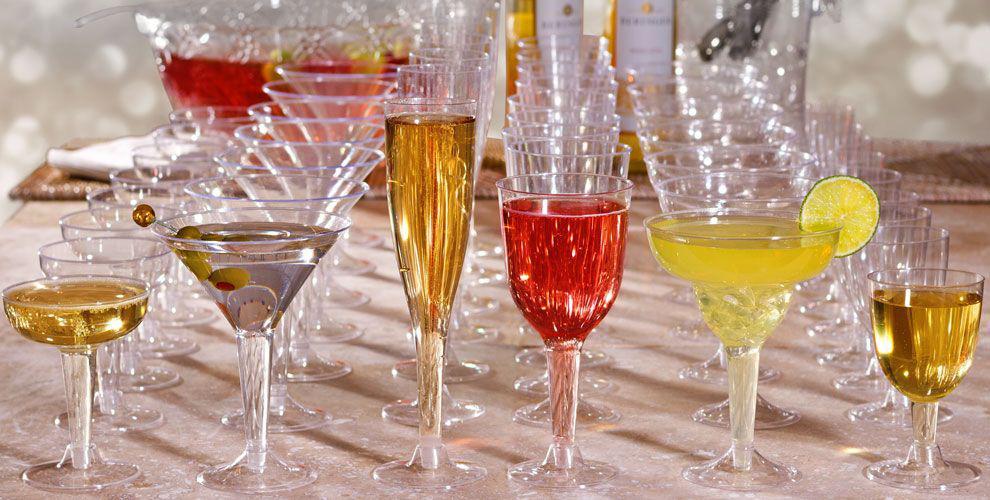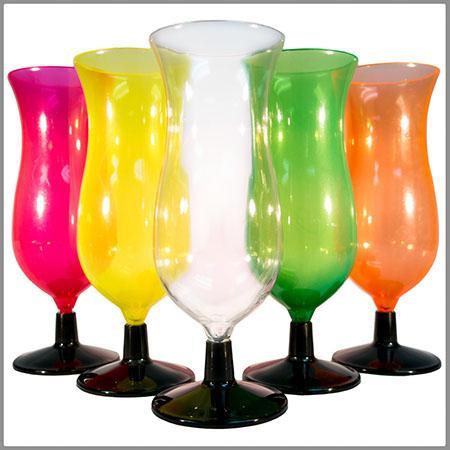The first image is the image on the left, the second image is the image on the right. For the images displayed, is the sentence "Some containers are empty." factually correct? Answer yes or no. Yes. The first image is the image on the left, the second image is the image on the right. Examine the images to the left and right. Is the description "There are no more than 2 cups in the left image, and they are all plastic." accurate? Answer yes or no. No. 